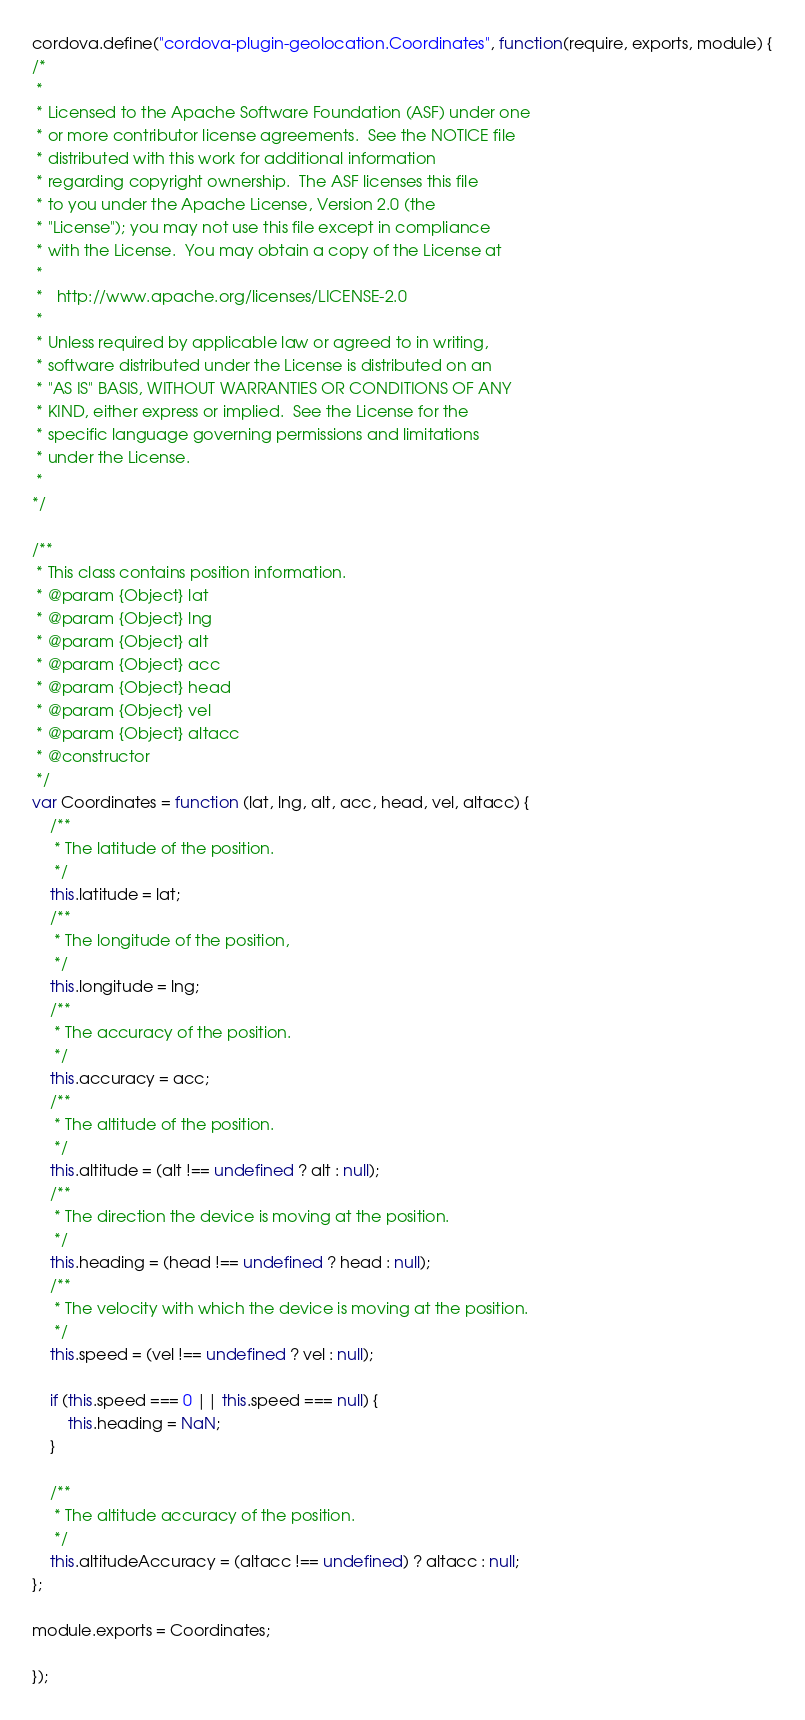Convert code to text. <code><loc_0><loc_0><loc_500><loc_500><_JavaScript_>cordova.define("cordova-plugin-geolocation.Coordinates", function(require, exports, module) {
/*
 *
 * Licensed to the Apache Software Foundation (ASF) under one
 * or more contributor license agreements.  See the NOTICE file
 * distributed with this work for additional information
 * regarding copyright ownership.  The ASF licenses this file
 * to you under the Apache License, Version 2.0 (the
 * "License"); you may not use this file except in compliance
 * with the License.  You may obtain a copy of the License at
 *
 *   http://www.apache.org/licenses/LICENSE-2.0
 *
 * Unless required by applicable law or agreed to in writing,
 * software distributed under the License is distributed on an
 * "AS IS" BASIS, WITHOUT WARRANTIES OR CONDITIONS OF ANY
 * KIND, either express or implied.  See the License for the
 * specific language governing permissions and limitations
 * under the License.
 *
*/

/**
 * This class contains position information.
 * @param {Object} lat
 * @param {Object} lng
 * @param {Object} alt
 * @param {Object} acc
 * @param {Object} head
 * @param {Object} vel
 * @param {Object} altacc
 * @constructor
 */
var Coordinates = function (lat, lng, alt, acc, head, vel, altacc) {
    /**
     * The latitude of the position.
     */
    this.latitude = lat;
    /**
     * The longitude of the position,
     */
    this.longitude = lng;
    /**
     * The accuracy of the position.
     */
    this.accuracy = acc;
    /**
     * The altitude of the position.
     */
    this.altitude = (alt !== undefined ? alt : null);
    /**
     * The direction the device is moving at the position.
     */
    this.heading = (head !== undefined ? head : null);
    /**
     * The velocity with which the device is moving at the position.
     */
    this.speed = (vel !== undefined ? vel : null);

    if (this.speed === 0 || this.speed === null) {
        this.heading = NaN;
    }

    /**
     * The altitude accuracy of the position.
     */
    this.altitudeAccuracy = (altacc !== undefined) ? altacc : null;
};

module.exports = Coordinates;

});
</code> 